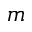<formula> <loc_0><loc_0><loc_500><loc_500>m</formula> 